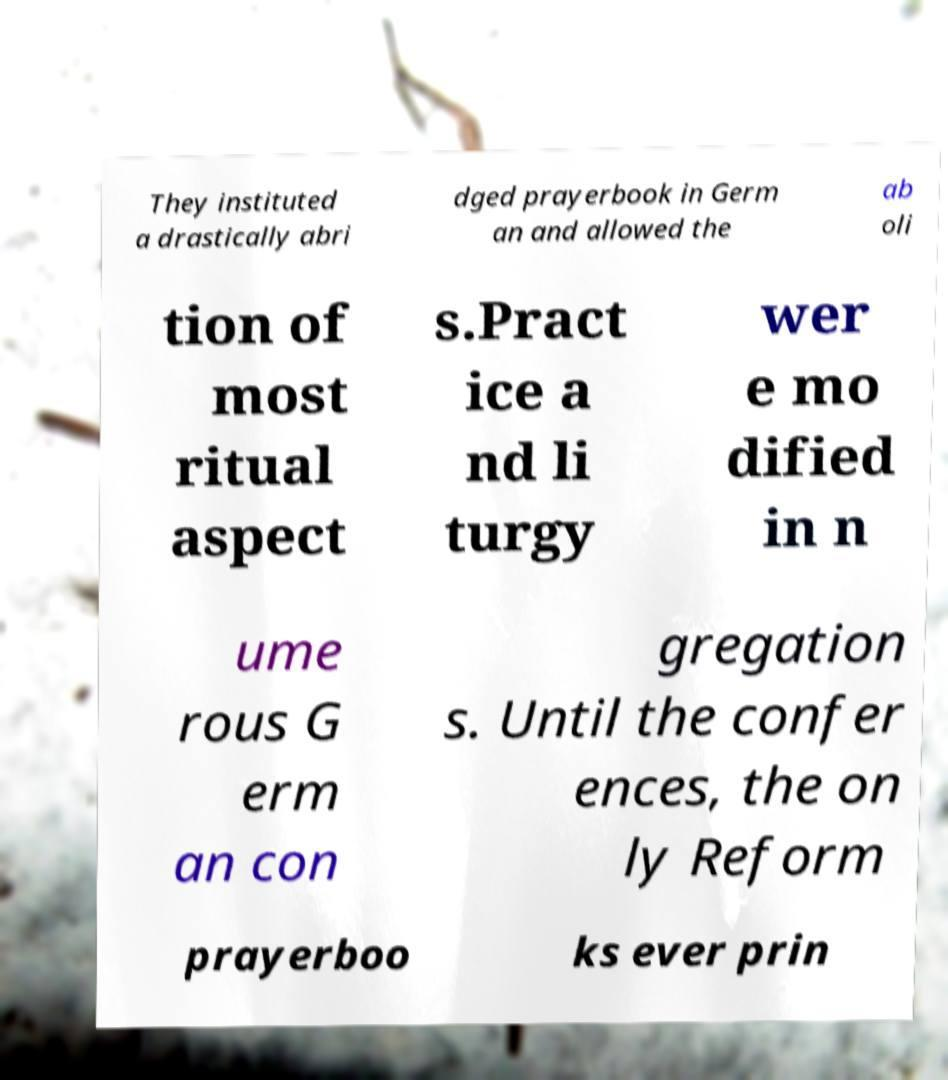I need the written content from this picture converted into text. Can you do that? They instituted a drastically abri dged prayerbook in Germ an and allowed the ab oli tion of most ritual aspect s.Pract ice a nd li turgy wer e mo dified in n ume rous G erm an con gregation s. Until the confer ences, the on ly Reform prayerboo ks ever prin 